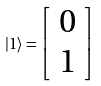Convert formula to latex. <formula><loc_0><loc_0><loc_500><loc_500>| 1 \rangle = { \left [ \begin{array} { l } { 0 } \\ { 1 } \end{array} \right ] }</formula> 